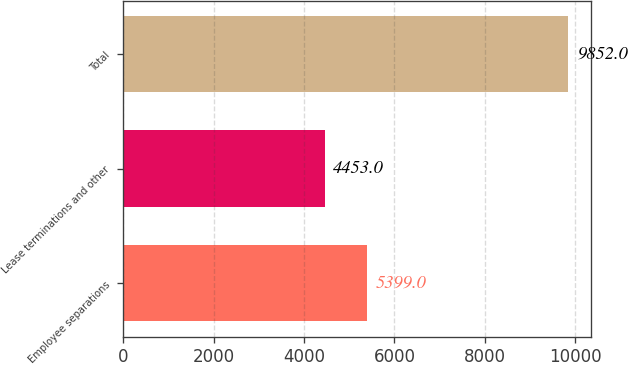<chart> <loc_0><loc_0><loc_500><loc_500><bar_chart><fcel>Employee separations<fcel>Lease terminations and other<fcel>Total<nl><fcel>5399<fcel>4453<fcel>9852<nl></chart> 